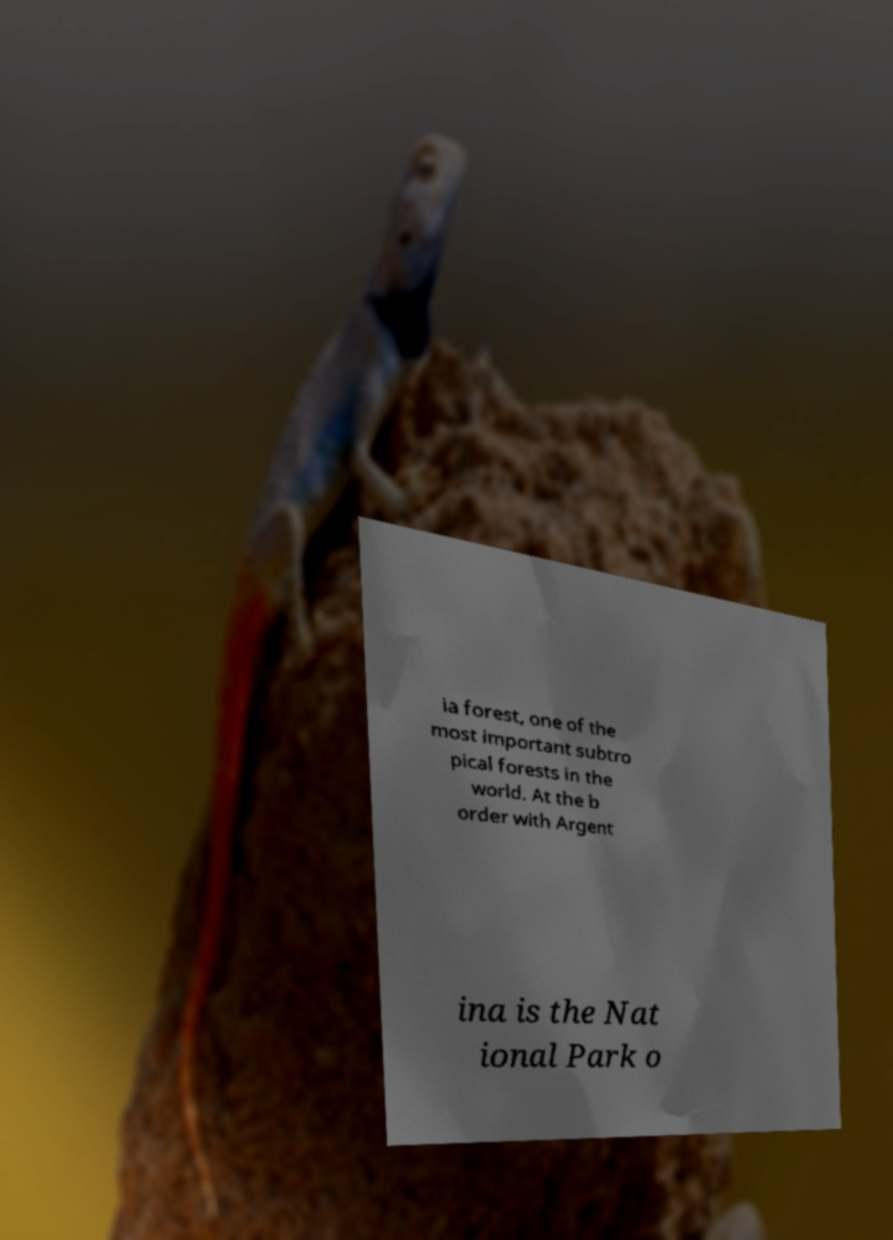For documentation purposes, I need the text within this image transcribed. Could you provide that? ia forest, one of the most important subtro pical forests in the world. At the b order with Argent ina is the Nat ional Park o 